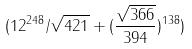<formula> <loc_0><loc_0><loc_500><loc_500>( 1 2 ^ { 2 4 8 } / \sqrt { 4 2 1 } + ( \frac { \sqrt { 3 6 6 } } { 3 9 4 } ) ^ { 1 3 8 } )</formula> 